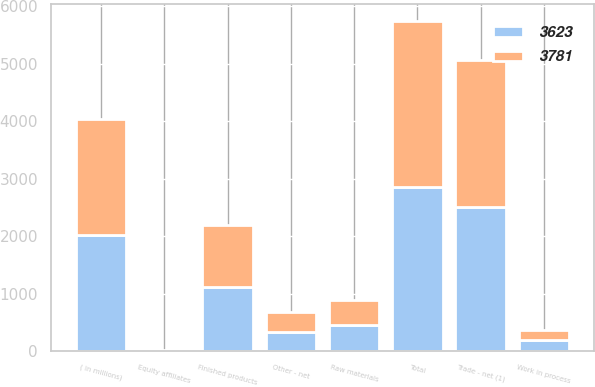Convert chart. <chart><loc_0><loc_0><loc_500><loc_500><stacked_bar_chart><ecel><fcel>( in millions)<fcel>Trade - net (1)<fcel>Equity affiliates<fcel>Other - net<fcel>Total<fcel>Finished products<fcel>Work in process<fcel>Raw materials<nl><fcel>3623<fcel>2018<fcel>2505<fcel>4<fcel>336<fcel>2845<fcel>1105<fcel>193<fcel>452<nl><fcel>3781<fcel>2017<fcel>2559<fcel>5<fcel>339<fcel>2903<fcel>1083<fcel>177<fcel>437<nl></chart> 